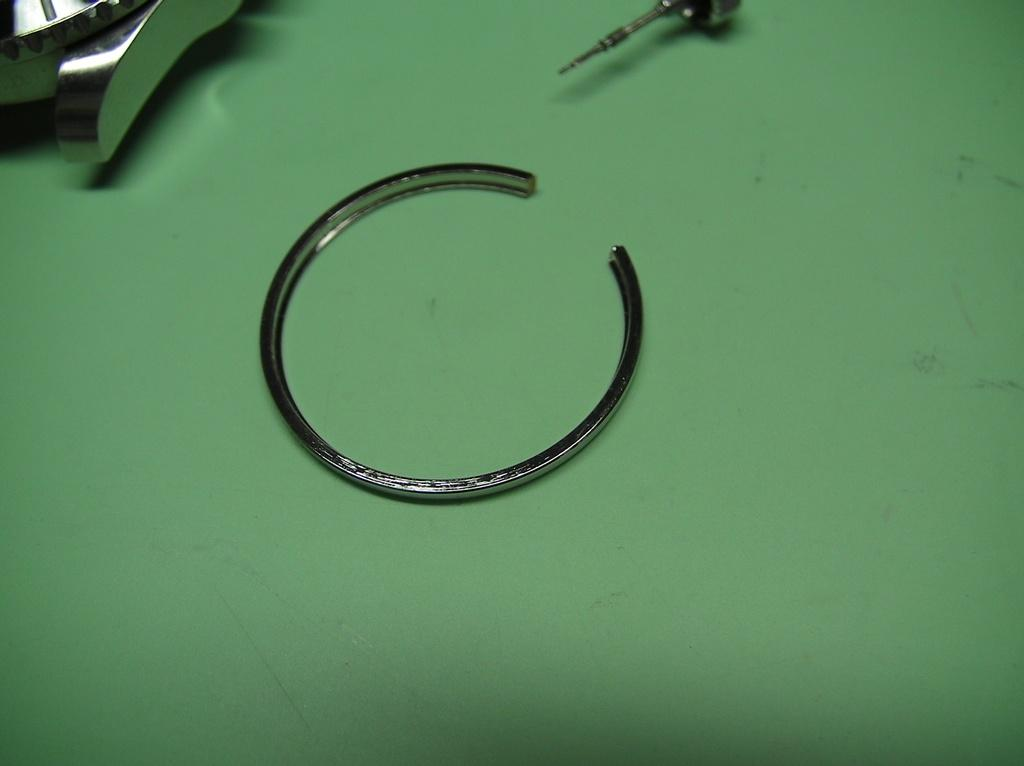What type of objects can be seen in the image? There are metallic objects in the image. What is the color of the surface beneath the metallic objects? The surface beneath the metallic objects is green in color. Are there any dinosaurs visible in the image? No, there are no dinosaurs present in the image. What type of stick can be seen in the image? There is no stick present in the image. 